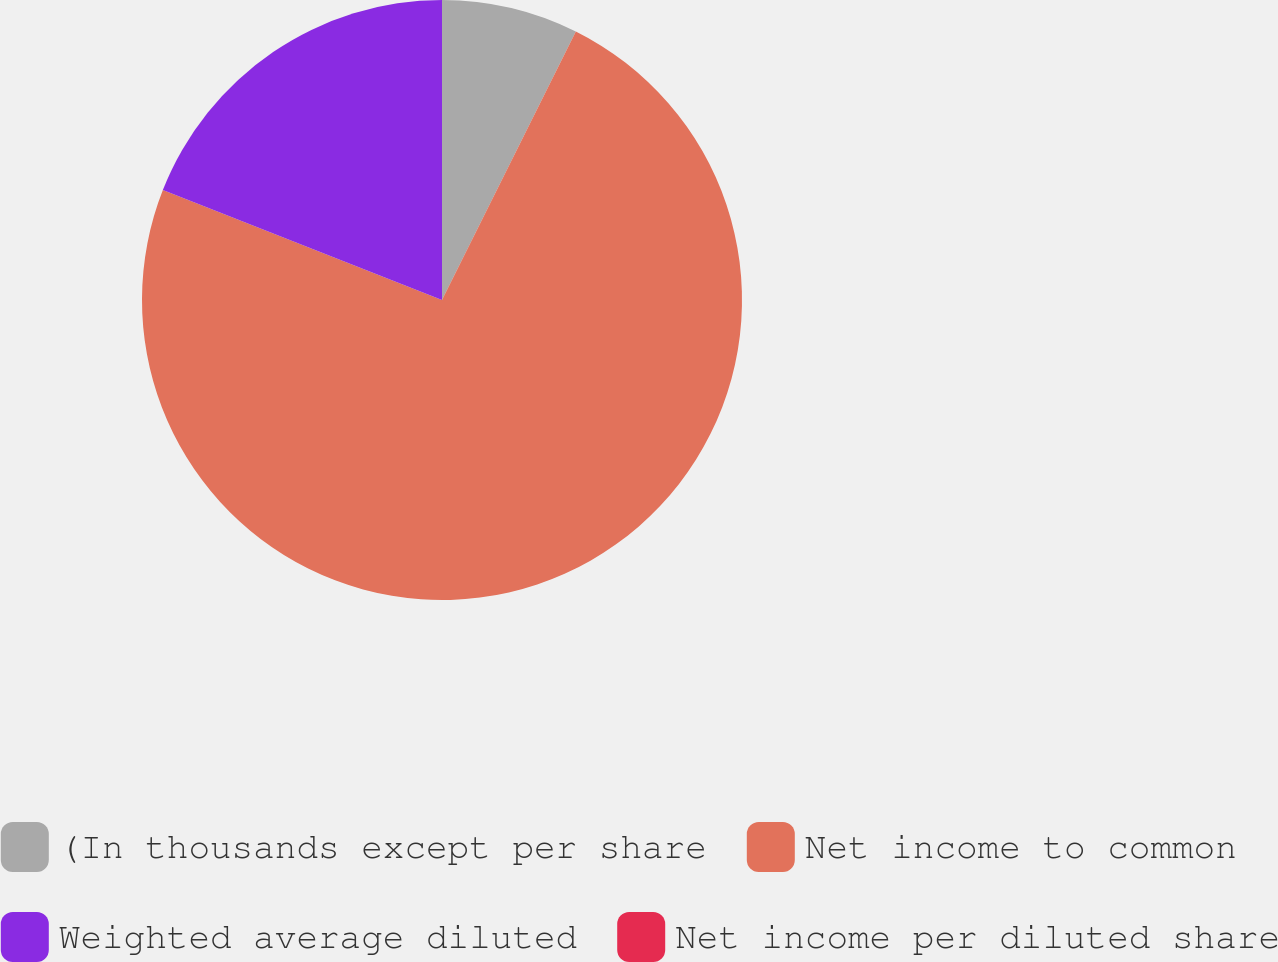Convert chart to OTSL. <chart><loc_0><loc_0><loc_500><loc_500><pie_chart><fcel>(In thousands except per share<fcel>Net income to common<fcel>Weighted average diluted<fcel>Net income per diluted share<nl><fcel>7.36%<fcel>73.61%<fcel>19.03%<fcel>0.0%<nl></chart> 